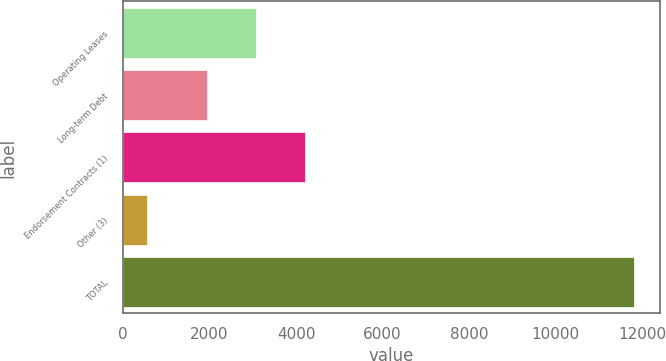<chart> <loc_0><loc_0><loc_500><loc_500><bar_chart><fcel>Operating Leases<fcel>Long-term Debt<fcel>Endorsement Contracts (1)<fcel>Other (3)<fcel>TOTAL<nl><fcel>3075.6<fcel>1949<fcel>4202.2<fcel>549<fcel>11815<nl></chart> 